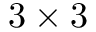Convert formula to latex. <formula><loc_0><loc_0><loc_500><loc_500>3 \times 3</formula> 